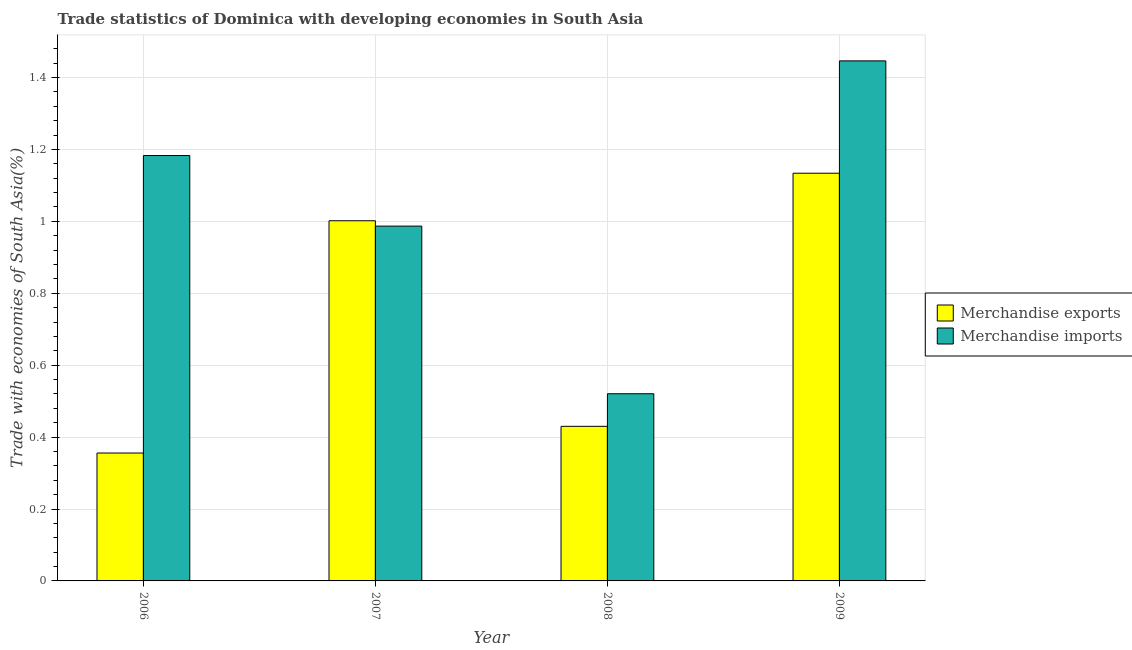How many different coloured bars are there?
Offer a very short reply. 2. Are the number of bars on each tick of the X-axis equal?
Give a very brief answer. Yes. How many bars are there on the 3rd tick from the left?
Keep it short and to the point. 2. In how many cases, is the number of bars for a given year not equal to the number of legend labels?
Ensure brevity in your answer.  0. What is the merchandise exports in 2009?
Give a very brief answer. 1.13. Across all years, what is the maximum merchandise exports?
Your response must be concise. 1.13. Across all years, what is the minimum merchandise imports?
Your answer should be compact. 0.52. In which year was the merchandise imports maximum?
Give a very brief answer. 2009. What is the total merchandise imports in the graph?
Provide a short and direct response. 4.14. What is the difference between the merchandise exports in 2006 and that in 2009?
Your answer should be compact. -0.78. What is the difference between the merchandise exports in 2008 and the merchandise imports in 2007?
Offer a very short reply. -0.57. What is the average merchandise imports per year?
Keep it short and to the point. 1.03. What is the ratio of the merchandise exports in 2006 to that in 2007?
Your response must be concise. 0.36. Is the difference between the merchandise imports in 2006 and 2007 greater than the difference between the merchandise exports in 2006 and 2007?
Keep it short and to the point. No. What is the difference between the highest and the second highest merchandise imports?
Provide a succinct answer. 0.26. What is the difference between the highest and the lowest merchandise exports?
Offer a very short reply. 0.78. In how many years, is the merchandise imports greater than the average merchandise imports taken over all years?
Ensure brevity in your answer.  2. Is the sum of the merchandise imports in 2006 and 2009 greater than the maximum merchandise exports across all years?
Your answer should be compact. Yes. What does the 1st bar from the left in 2009 represents?
Your answer should be compact. Merchandise exports. How many bars are there?
Give a very brief answer. 8. Are all the bars in the graph horizontal?
Make the answer very short. No. How many years are there in the graph?
Provide a short and direct response. 4. What is the difference between two consecutive major ticks on the Y-axis?
Offer a terse response. 0.2. Are the values on the major ticks of Y-axis written in scientific E-notation?
Provide a short and direct response. No. How are the legend labels stacked?
Ensure brevity in your answer.  Vertical. What is the title of the graph?
Provide a succinct answer. Trade statistics of Dominica with developing economies in South Asia. Does "Primary completion rate" appear as one of the legend labels in the graph?
Your answer should be very brief. No. What is the label or title of the X-axis?
Provide a short and direct response. Year. What is the label or title of the Y-axis?
Give a very brief answer. Trade with economies of South Asia(%). What is the Trade with economies of South Asia(%) in Merchandise exports in 2006?
Your answer should be compact. 0.36. What is the Trade with economies of South Asia(%) in Merchandise imports in 2006?
Keep it short and to the point. 1.18. What is the Trade with economies of South Asia(%) in Merchandise exports in 2007?
Make the answer very short. 1. What is the Trade with economies of South Asia(%) of Merchandise imports in 2007?
Offer a very short reply. 0.99. What is the Trade with economies of South Asia(%) of Merchandise exports in 2008?
Provide a short and direct response. 0.43. What is the Trade with economies of South Asia(%) of Merchandise imports in 2008?
Your response must be concise. 0.52. What is the Trade with economies of South Asia(%) in Merchandise exports in 2009?
Offer a very short reply. 1.13. What is the Trade with economies of South Asia(%) of Merchandise imports in 2009?
Keep it short and to the point. 1.45. Across all years, what is the maximum Trade with economies of South Asia(%) in Merchandise exports?
Your answer should be compact. 1.13. Across all years, what is the maximum Trade with economies of South Asia(%) of Merchandise imports?
Make the answer very short. 1.45. Across all years, what is the minimum Trade with economies of South Asia(%) in Merchandise exports?
Offer a very short reply. 0.36. Across all years, what is the minimum Trade with economies of South Asia(%) of Merchandise imports?
Your response must be concise. 0.52. What is the total Trade with economies of South Asia(%) of Merchandise exports in the graph?
Keep it short and to the point. 2.92. What is the total Trade with economies of South Asia(%) of Merchandise imports in the graph?
Your response must be concise. 4.14. What is the difference between the Trade with economies of South Asia(%) of Merchandise exports in 2006 and that in 2007?
Your answer should be very brief. -0.65. What is the difference between the Trade with economies of South Asia(%) of Merchandise imports in 2006 and that in 2007?
Your response must be concise. 0.2. What is the difference between the Trade with economies of South Asia(%) in Merchandise exports in 2006 and that in 2008?
Offer a very short reply. -0.07. What is the difference between the Trade with economies of South Asia(%) in Merchandise imports in 2006 and that in 2008?
Your answer should be very brief. 0.66. What is the difference between the Trade with economies of South Asia(%) of Merchandise exports in 2006 and that in 2009?
Ensure brevity in your answer.  -0.78. What is the difference between the Trade with economies of South Asia(%) of Merchandise imports in 2006 and that in 2009?
Ensure brevity in your answer.  -0.26. What is the difference between the Trade with economies of South Asia(%) in Merchandise exports in 2007 and that in 2008?
Provide a short and direct response. 0.57. What is the difference between the Trade with economies of South Asia(%) of Merchandise imports in 2007 and that in 2008?
Keep it short and to the point. 0.47. What is the difference between the Trade with economies of South Asia(%) of Merchandise exports in 2007 and that in 2009?
Keep it short and to the point. -0.13. What is the difference between the Trade with economies of South Asia(%) of Merchandise imports in 2007 and that in 2009?
Your answer should be very brief. -0.46. What is the difference between the Trade with economies of South Asia(%) in Merchandise exports in 2008 and that in 2009?
Your response must be concise. -0.7. What is the difference between the Trade with economies of South Asia(%) of Merchandise imports in 2008 and that in 2009?
Make the answer very short. -0.93. What is the difference between the Trade with economies of South Asia(%) of Merchandise exports in 2006 and the Trade with economies of South Asia(%) of Merchandise imports in 2007?
Keep it short and to the point. -0.63. What is the difference between the Trade with economies of South Asia(%) in Merchandise exports in 2006 and the Trade with economies of South Asia(%) in Merchandise imports in 2008?
Keep it short and to the point. -0.16. What is the difference between the Trade with economies of South Asia(%) of Merchandise exports in 2006 and the Trade with economies of South Asia(%) of Merchandise imports in 2009?
Offer a very short reply. -1.09. What is the difference between the Trade with economies of South Asia(%) of Merchandise exports in 2007 and the Trade with economies of South Asia(%) of Merchandise imports in 2008?
Your response must be concise. 0.48. What is the difference between the Trade with economies of South Asia(%) of Merchandise exports in 2007 and the Trade with economies of South Asia(%) of Merchandise imports in 2009?
Make the answer very short. -0.44. What is the difference between the Trade with economies of South Asia(%) of Merchandise exports in 2008 and the Trade with economies of South Asia(%) of Merchandise imports in 2009?
Ensure brevity in your answer.  -1.02. What is the average Trade with economies of South Asia(%) of Merchandise exports per year?
Ensure brevity in your answer.  0.73. What is the average Trade with economies of South Asia(%) of Merchandise imports per year?
Offer a terse response. 1.03. In the year 2006, what is the difference between the Trade with economies of South Asia(%) in Merchandise exports and Trade with economies of South Asia(%) in Merchandise imports?
Provide a succinct answer. -0.83. In the year 2007, what is the difference between the Trade with economies of South Asia(%) in Merchandise exports and Trade with economies of South Asia(%) in Merchandise imports?
Provide a short and direct response. 0.01. In the year 2008, what is the difference between the Trade with economies of South Asia(%) of Merchandise exports and Trade with economies of South Asia(%) of Merchandise imports?
Your answer should be very brief. -0.09. In the year 2009, what is the difference between the Trade with economies of South Asia(%) in Merchandise exports and Trade with economies of South Asia(%) in Merchandise imports?
Provide a succinct answer. -0.31. What is the ratio of the Trade with economies of South Asia(%) in Merchandise exports in 2006 to that in 2007?
Your response must be concise. 0.36. What is the ratio of the Trade with economies of South Asia(%) in Merchandise imports in 2006 to that in 2007?
Keep it short and to the point. 1.2. What is the ratio of the Trade with economies of South Asia(%) of Merchandise exports in 2006 to that in 2008?
Give a very brief answer. 0.83. What is the ratio of the Trade with economies of South Asia(%) in Merchandise imports in 2006 to that in 2008?
Keep it short and to the point. 2.27. What is the ratio of the Trade with economies of South Asia(%) of Merchandise exports in 2006 to that in 2009?
Keep it short and to the point. 0.31. What is the ratio of the Trade with economies of South Asia(%) in Merchandise imports in 2006 to that in 2009?
Make the answer very short. 0.82. What is the ratio of the Trade with economies of South Asia(%) in Merchandise exports in 2007 to that in 2008?
Your response must be concise. 2.33. What is the ratio of the Trade with economies of South Asia(%) of Merchandise imports in 2007 to that in 2008?
Your answer should be compact. 1.9. What is the ratio of the Trade with economies of South Asia(%) of Merchandise exports in 2007 to that in 2009?
Keep it short and to the point. 0.88. What is the ratio of the Trade with economies of South Asia(%) in Merchandise imports in 2007 to that in 2009?
Provide a succinct answer. 0.68. What is the ratio of the Trade with economies of South Asia(%) in Merchandise exports in 2008 to that in 2009?
Keep it short and to the point. 0.38. What is the ratio of the Trade with economies of South Asia(%) in Merchandise imports in 2008 to that in 2009?
Your response must be concise. 0.36. What is the difference between the highest and the second highest Trade with economies of South Asia(%) in Merchandise exports?
Ensure brevity in your answer.  0.13. What is the difference between the highest and the second highest Trade with economies of South Asia(%) of Merchandise imports?
Ensure brevity in your answer.  0.26. What is the difference between the highest and the lowest Trade with economies of South Asia(%) of Merchandise exports?
Make the answer very short. 0.78. What is the difference between the highest and the lowest Trade with economies of South Asia(%) of Merchandise imports?
Your answer should be very brief. 0.93. 